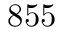<formula> <loc_0><loc_0><loc_500><loc_500>8 5 5</formula> 